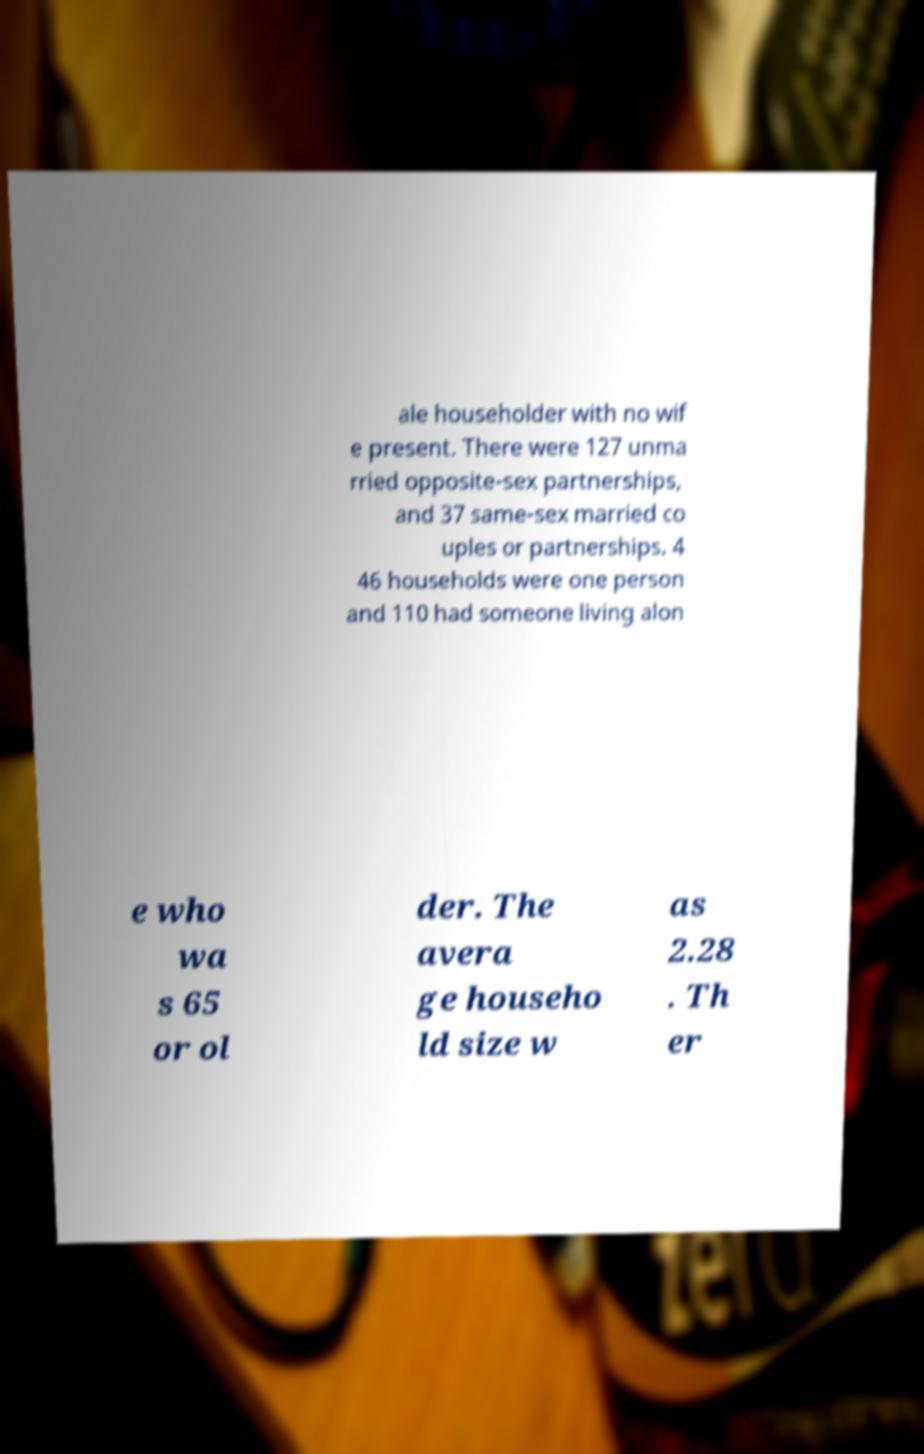For documentation purposes, I need the text within this image transcribed. Could you provide that? ale householder with no wif e present. There were 127 unma rried opposite-sex partnerships, and 37 same-sex married co uples or partnerships. 4 46 households were one person and 110 had someone living alon e who wa s 65 or ol der. The avera ge househo ld size w as 2.28 . Th er 